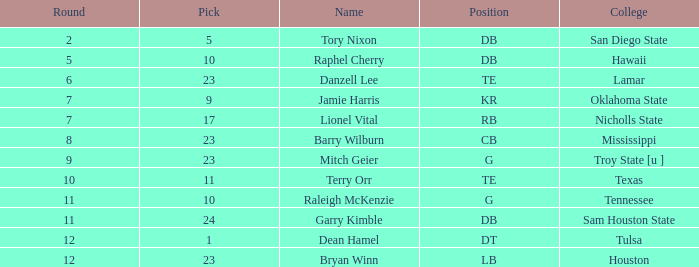How many Picks have an Overall smaller than 304, and a Position of g, and a Round smaller than 11? 1.0. 